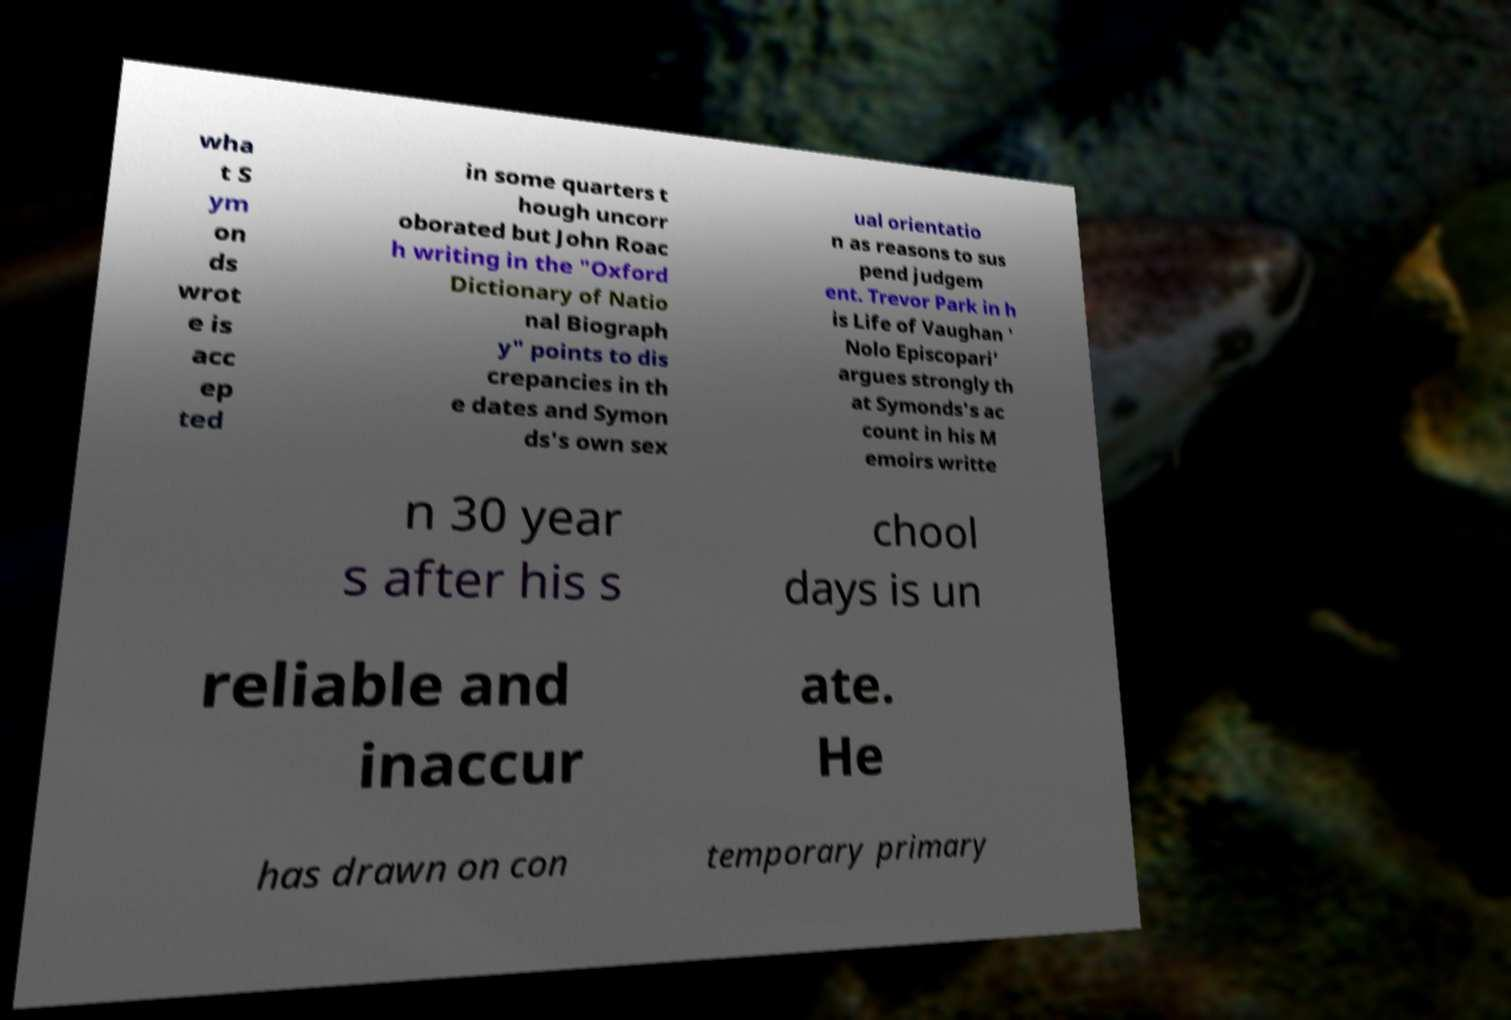Could you assist in decoding the text presented in this image and type it out clearly? wha t S ym on ds wrot e is acc ep ted in some quarters t hough uncorr oborated but John Roac h writing in the "Oxford Dictionary of Natio nal Biograph y" points to dis crepancies in th e dates and Symon ds's own sex ual orientatio n as reasons to sus pend judgem ent. Trevor Park in h is Life of Vaughan ' Nolo Episcopari' argues strongly th at Symonds's ac count in his M emoirs writte n 30 year s after his s chool days is un reliable and inaccur ate. He has drawn on con temporary primary 